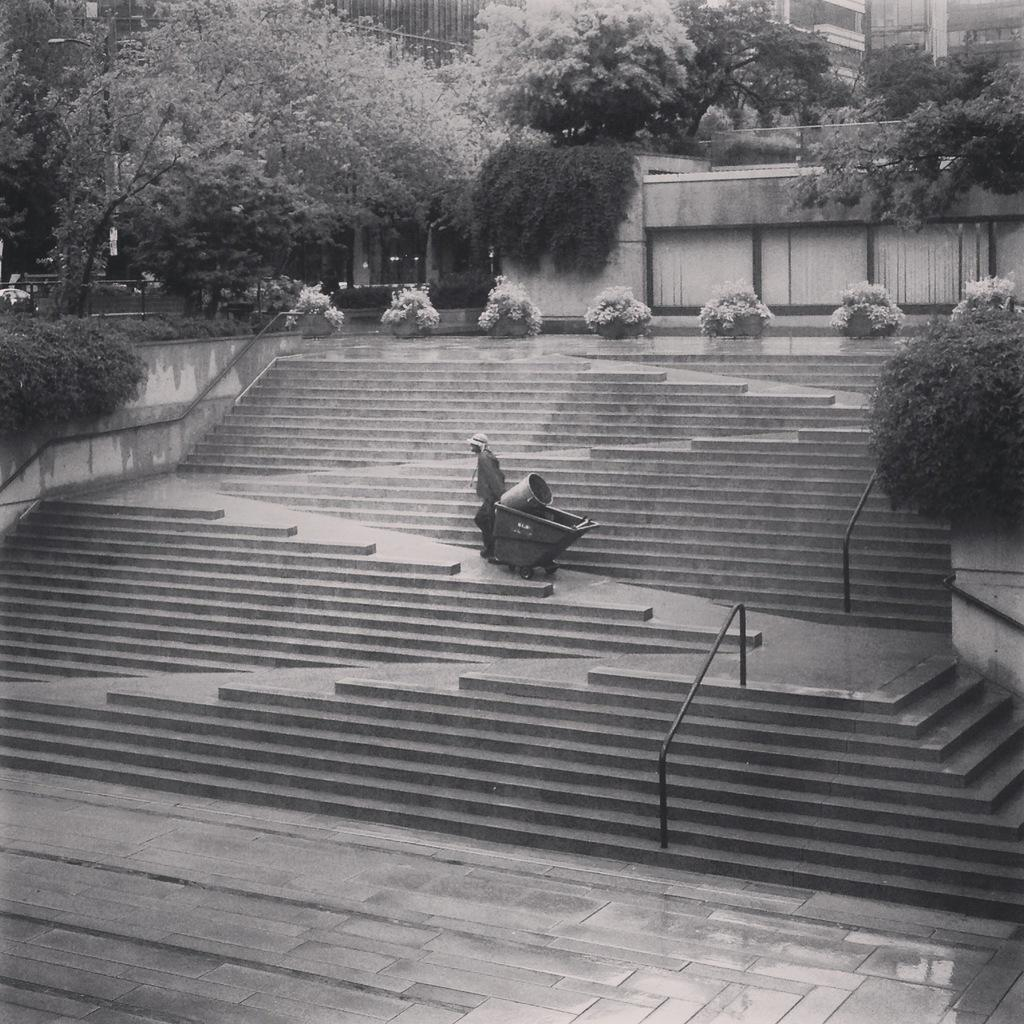What is the main subject of the image? There is a person in the image. What is the person holding in the image? The person is holding a trolley. What is the person doing in the image? The person is walking on stairs. What is the color scheme of the image? The image is in black and white. What can be seen in the background of the image? There are buildings and trees in the background of the image. How many babies are sitting on the secretary's desk in the image? There is no secretary or babies present in the image. What type of salt is being used to season the person's food in the image? There is no salt or food visible in the image. 